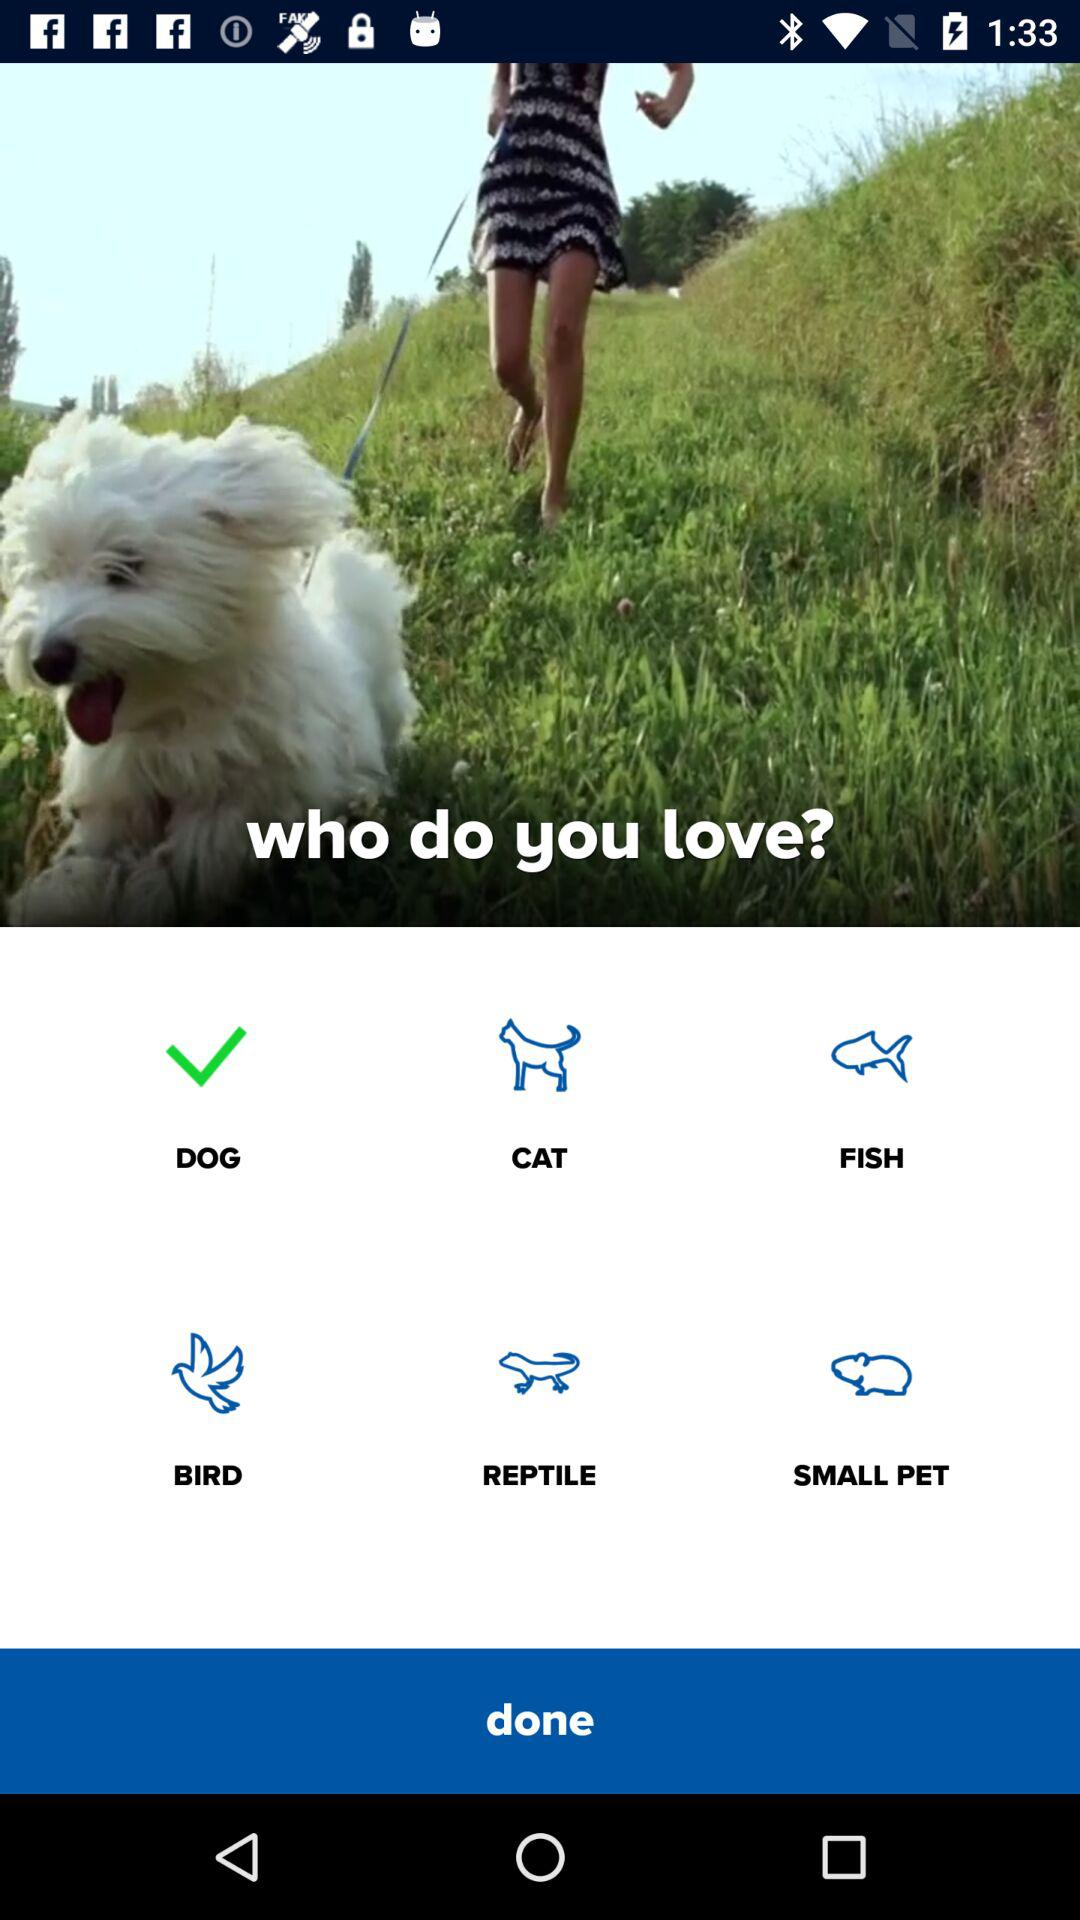Which animal has been selected? The animal that has been selected is "DOG". 